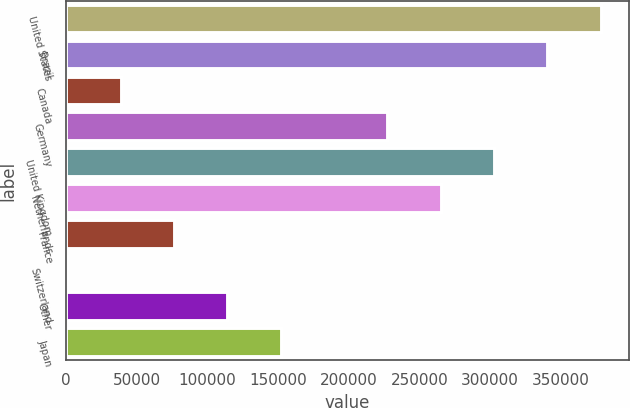Convert chart to OTSL. <chart><loc_0><loc_0><loc_500><loc_500><bar_chart><fcel>United States<fcel>Brazil<fcel>Canada<fcel>Germany<fcel>United Kingdom<fcel>Netherlands<fcel>France<fcel>Switzerland<fcel>Other<fcel>Japan<nl><fcel>379096<fcel>341362<fcel>39489.1<fcel>228160<fcel>303628<fcel>265894<fcel>77223.2<fcel>1755<fcel>114957<fcel>152691<nl></chart> 